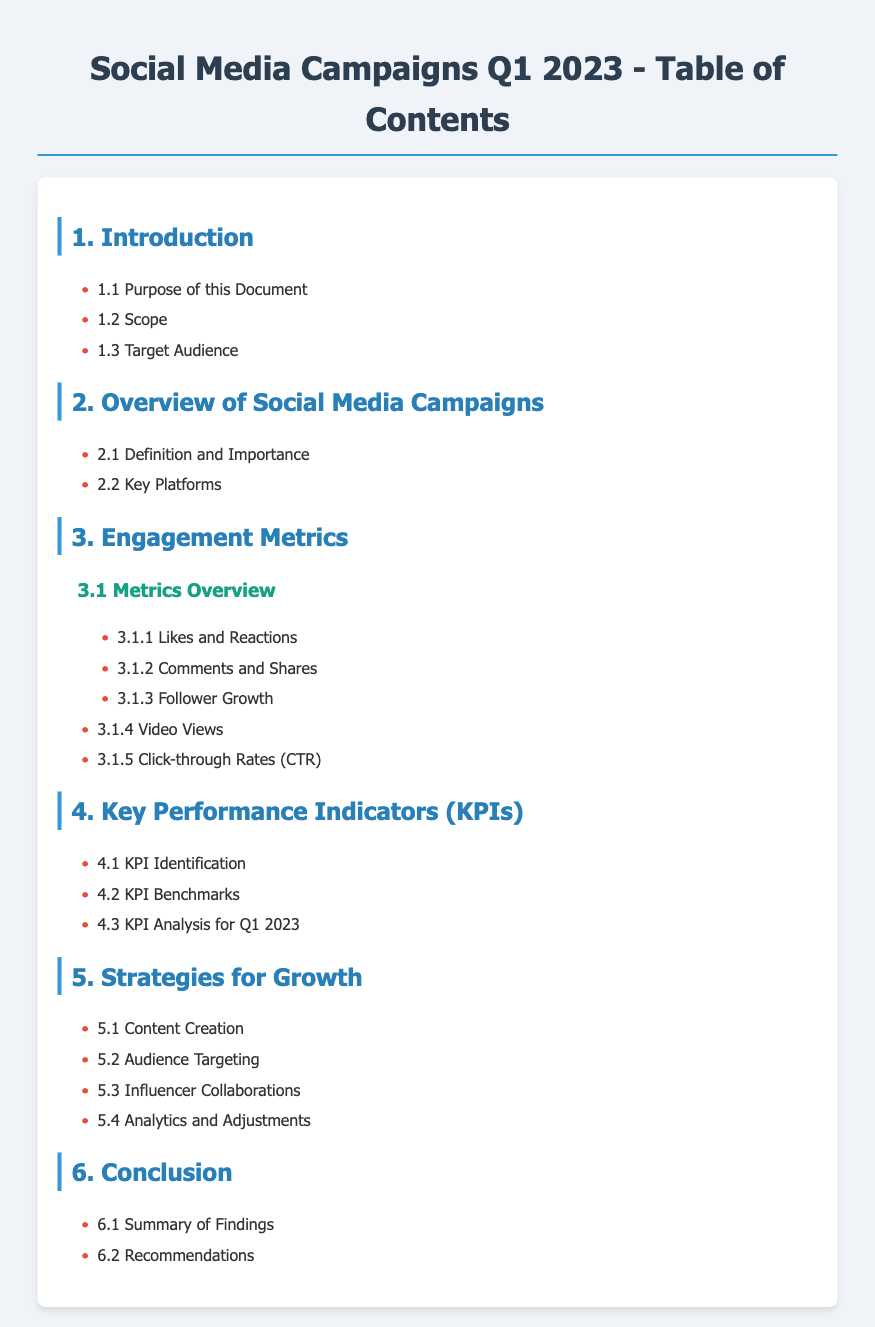What is the purpose of this document? The purpose is outlined in section 1.1 of the document.
Answer: To analyze engagement metrics, key performance indicators, and strategies for growth for Q1 2023 What are the key platforms mentioned? The key platforms are detailed in section 2.2.
Answer: Key Platforms What are the two main types of engagement metrics? Two main types are listed in section 3.1 under the respective items.
Answer: Likes and Reactions, Comments and Shares How many KPIs are identified in the document? KPIs are covered in section 4.1, specifically mentioning KPI Identification.
Answer: Three What is one strategy for growth listed? Strategies for growth are discussed in section 5, any specific strategy can be noted from section 5.1 to 5.4.
Answer: Content Creation What is the last section of the table of contents? The last section is outlined in section 6 of the document.
Answer: Conclusion What does section 3.1.3 focus on? This section addresses a specific engagement metric under engagement metrics.
Answer: Follower Growth What is the summary of findings located? The summary of findings can be found in the last section of the document.
Answer: 6.1 Summary of Findings 